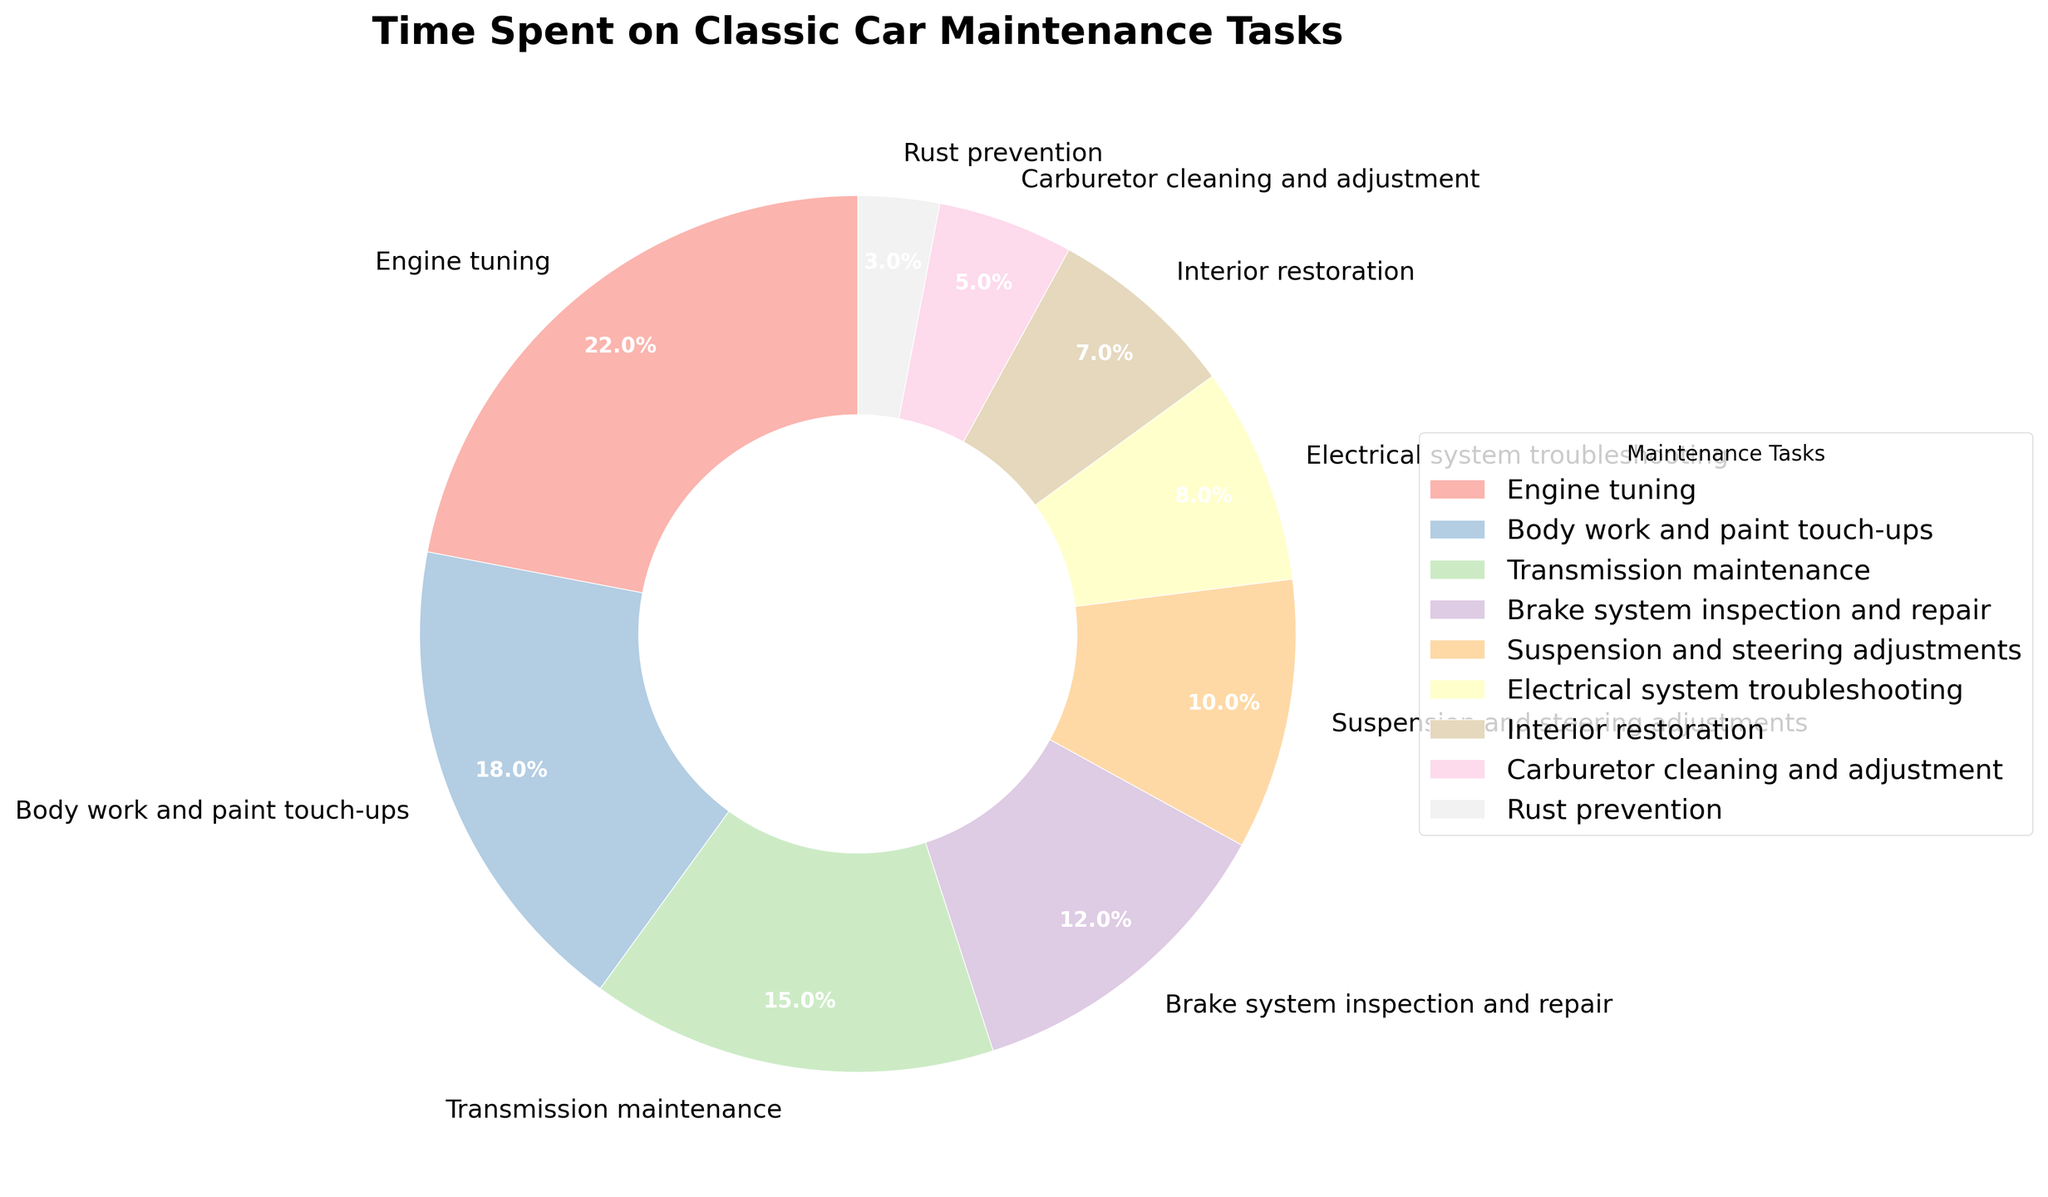What's the total percentage of time spent on engine tuning and brake system inspection and repair? To find the total percentage of time spent on engine tuning and brake system inspection and repair, sum the individual percentages of these tasks. Engine tuning takes 22%, and brake system inspection and repair takes 12%. Therefore, 22% + 12% = 34%.
Answer: 34% Which maintenance task takes the least amount of time? By inspecting the percentages, rust prevention has the smallest percentage at 3%.
Answer: Rust prevention How much more time is spent on engine tuning compared to carburetor cleaning and adjustment? To determine the difference in time spent, subtract the percentage of carburetor cleaning and adjustment from that of engine tuning. Engine tuning is 22%, and carburetor cleaning and adjustment is 5%. Therefore, 22% - 5% = 17%.
Answer: 17% Which maintenance tasks together make up more than 50% of the total time? To determine which tasks together exceed 50%, add the percentages starting from the highest until you surpass 50%. Engine tuning (22%) + Body work and paint touch-ups (18%) + Transmission maintenance (15%) = 55%.
Answer: Engine tuning, body work and paint touch-ups, transmission maintenance Is more time spent on electrical system troubleshooting or interior restoration? Compare the percentages of electrical system troubleshooting (8%) and interior restoration (7%). Since 8% is greater than 7%, more time is spent on electrical system troubleshooting.
Answer: Electrical system troubleshooting What percentage of time is spent on tasks related to paint and rust? Add the percentages of body work and paint touch-ups (18%) and rust prevention (3%). Therefore, 18% + 3% = 21%.
Answer: 21% How much less time is spent on suspension and steering adjustments compared to engine tuning? Subtract the percentage of suspension and steering adjustments (10%) from engine tuning (22%). Therefore, 22% - 10% = 12%.
Answer: 12% What is the combined percentage of time spent on brake system inspection and suspension and steering adjustments? Add the percentages of brake system inspection and repair (12%) and suspension and steering adjustments (10%). Therefore, 12% + 10% = 22%.
Answer: 22% Identify the maintenance task that takes just slightly more time than electrical system troubleshooting. Compare the percentages to find the task with a percentage just above 8%. Suspension and steering adjustments take 10%, which is slightly more than 8%.
Answer: Suspension and steering adjustments Which tasks are grouped under tasks occupying less than 10% of time each? Scan the tasks and their percentages to identify those below 10%. Electrical system troubleshooting (8%), interior restoration (7%), carburetor cleaning and adjustment (5%), and rust prevention (3%) all occupy less than 10% of the time each.
Answer: Electrical system troubleshooting, interior restoration, carburetor cleaning and adjustment, rust prevention 